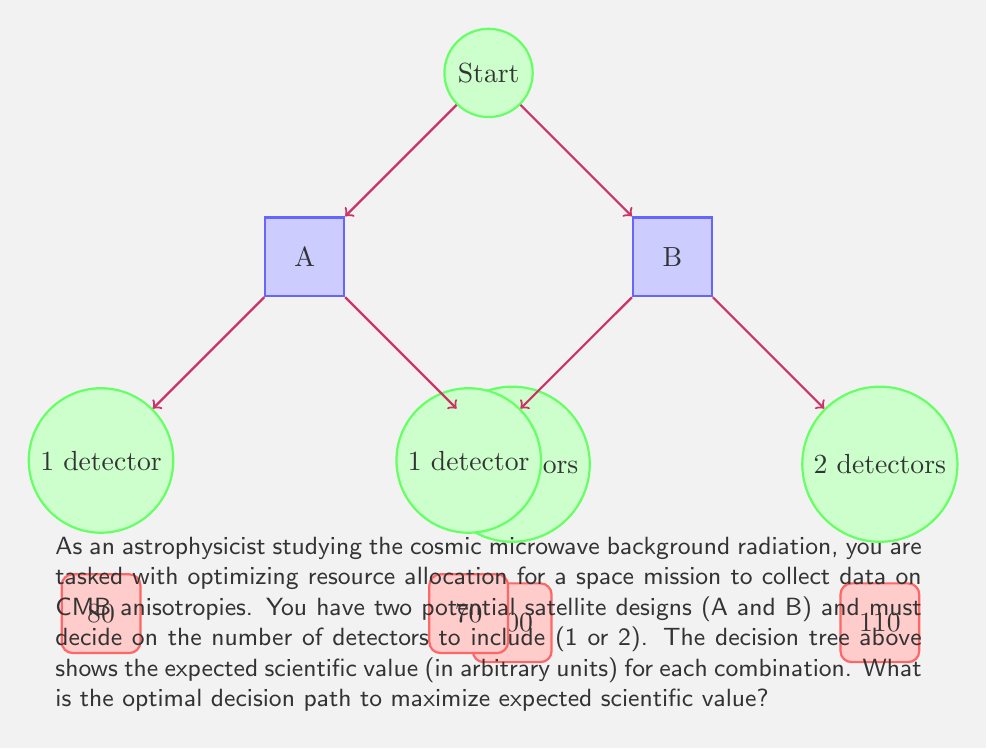Teach me how to tackle this problem. To optimize resource allocation using decision trees, we need to work backwards from the end nodes to the root, choosing the option that maximizes expected value at each decision point.

Step 1: Evaluate the terminal nodes
- Satellite A with 1 detector: 80
- Satellite A with 2 detectors: 100
- Satellite B with 1 detector: 70
- Satellite B with 2 detectors: 110

Step 2: Determine the best choice for each satellite design
For Satellite A:
$$\max(80, 100) = 100$$
The optimal choice for Satellite A is 2 detectors.

For Satellite B:
$$\max(70, 110) = 110$$
The optimal choice for Satellite B is 2 detectors.

Step 3: Compare the best outcomes for each satellite design
$$\max(100, 110) = 110$$
The overall optimal choice is Satellite B with 2 detectors.

Therefore, the optimal decision path to maximize expected scientific value is to choose Satellite B and equip it with 2 detectors, yielding an expected scientific value of 110 units.
Answer: Choose Satellite B with 2 detectors (110 units) 